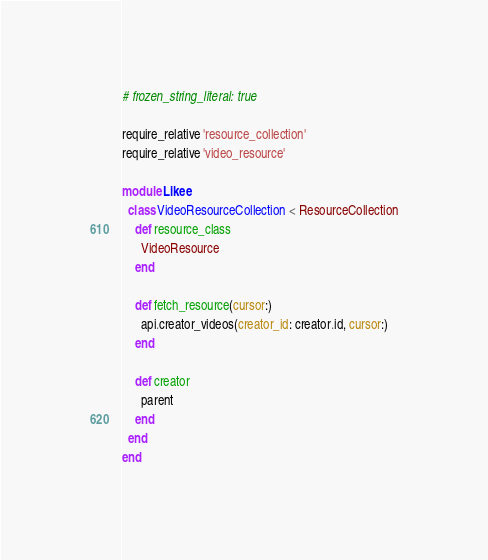Convert code to text. <code><loc_0><loc_0><loc_500><loc_500><_Ruby_># frozen_string_literal: true

require_relative 'resource_collection'
require_relative 'video_resource'

module Likee
  class VideoResourceCollection < ResourceCollection
    def resource_class
      VideoResource
    end

    def fetch_resource(cursor:)
      api.creator_videos(creator_id: creator.id, cursor:)
    end

    def creator
      parent
    end
  end
end
</code> 